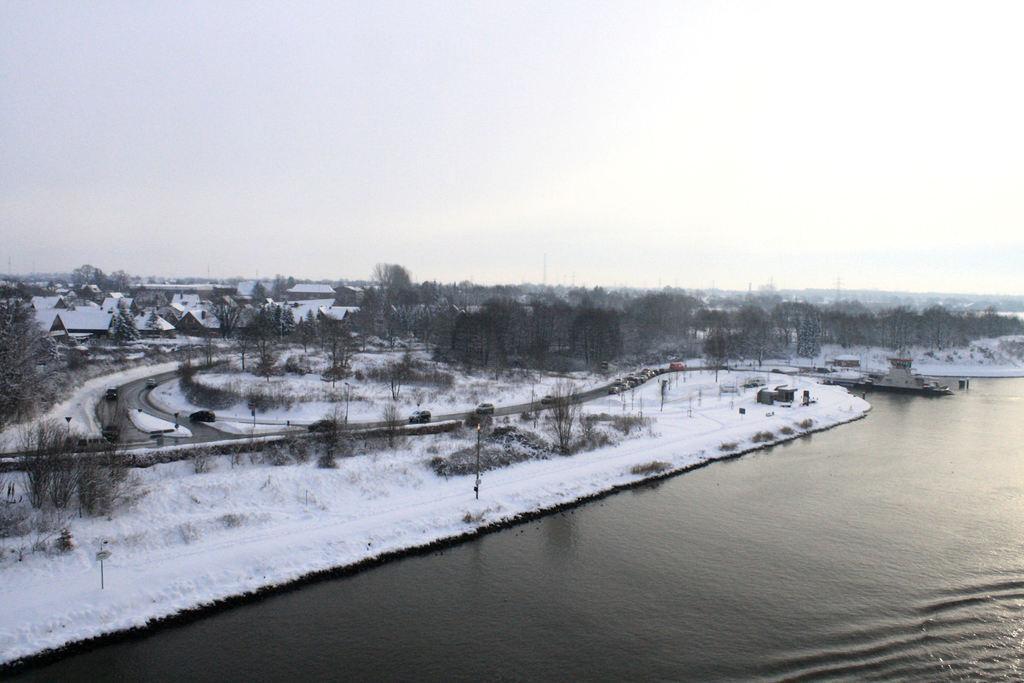Describe this image in one or two sentences. In the picture we can see a water, besides to it we can see a snow surface on it we can see some roads, trees and in the background we can see a sky. 